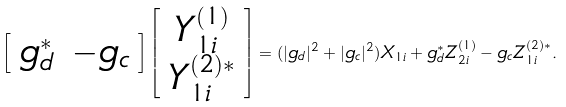Convert formula to latex. <formula><loc_0><loc_0><loc_500><loc_500>\left [ \begin{array} { c c } g _ { d } ^ { * } & - g _ { c } \end{array} \right ] \left [ \begin{array} { c } Y _ { 1 i } ^ { ( 1 ) } \\ Y _ { 1 i } ^ { ( 2 ) * } \\ \end{array} \right ] = ( | g _ { d } | ^ { 2 } + | g _ { c } | ^ { 2 } ) X _ { 1 i } + g _ { d } ^ { * } Z _ { 2 i } ^ { ( 1 ) } - g _ { c } Z _ { 1 i } ^ { ( 2 ) * } .</formula> 